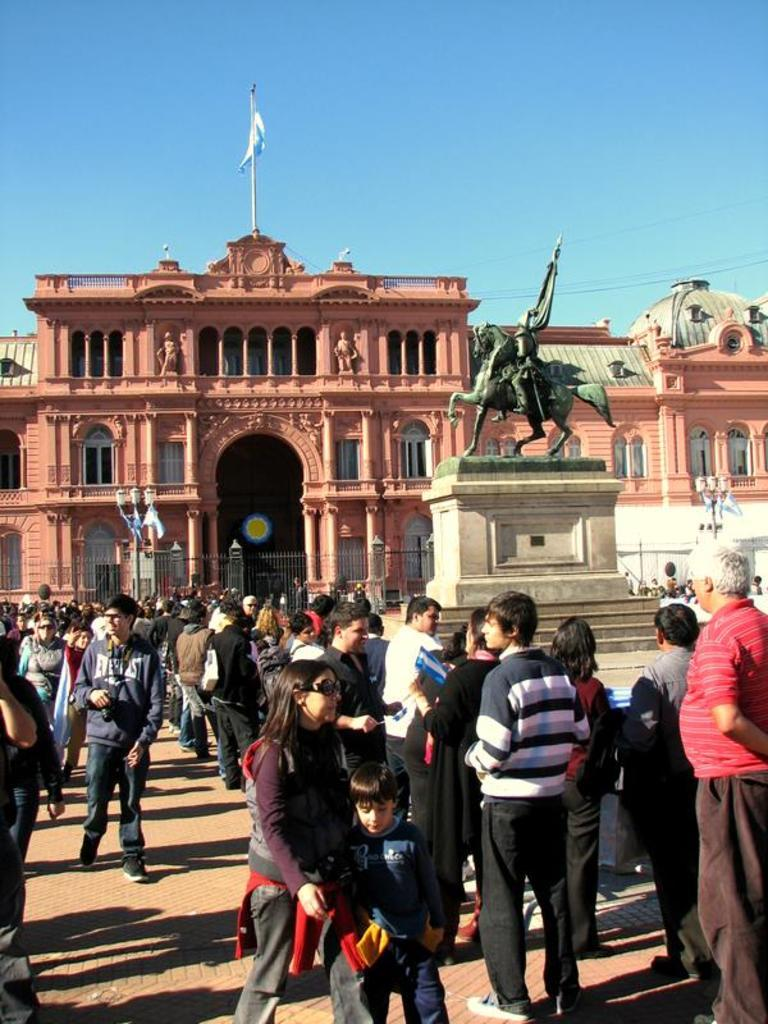Who or what can be seen in the image? There are people in the image. What is another prominent feature in the image? There is a statue in the image. What type of structures are visible in the image? There are houses in the image. Are there any symbols or markers in the image? Yes, there are flags in the image. What type of barrier can be seen in the image? There is fencing in the image. What part of the natural environment is visible in the image? The sky is visible in the image. Where is the toad located in the image? There is no toad present in the image. What type of bath can be seen in the image? There is no bath present in the image. 